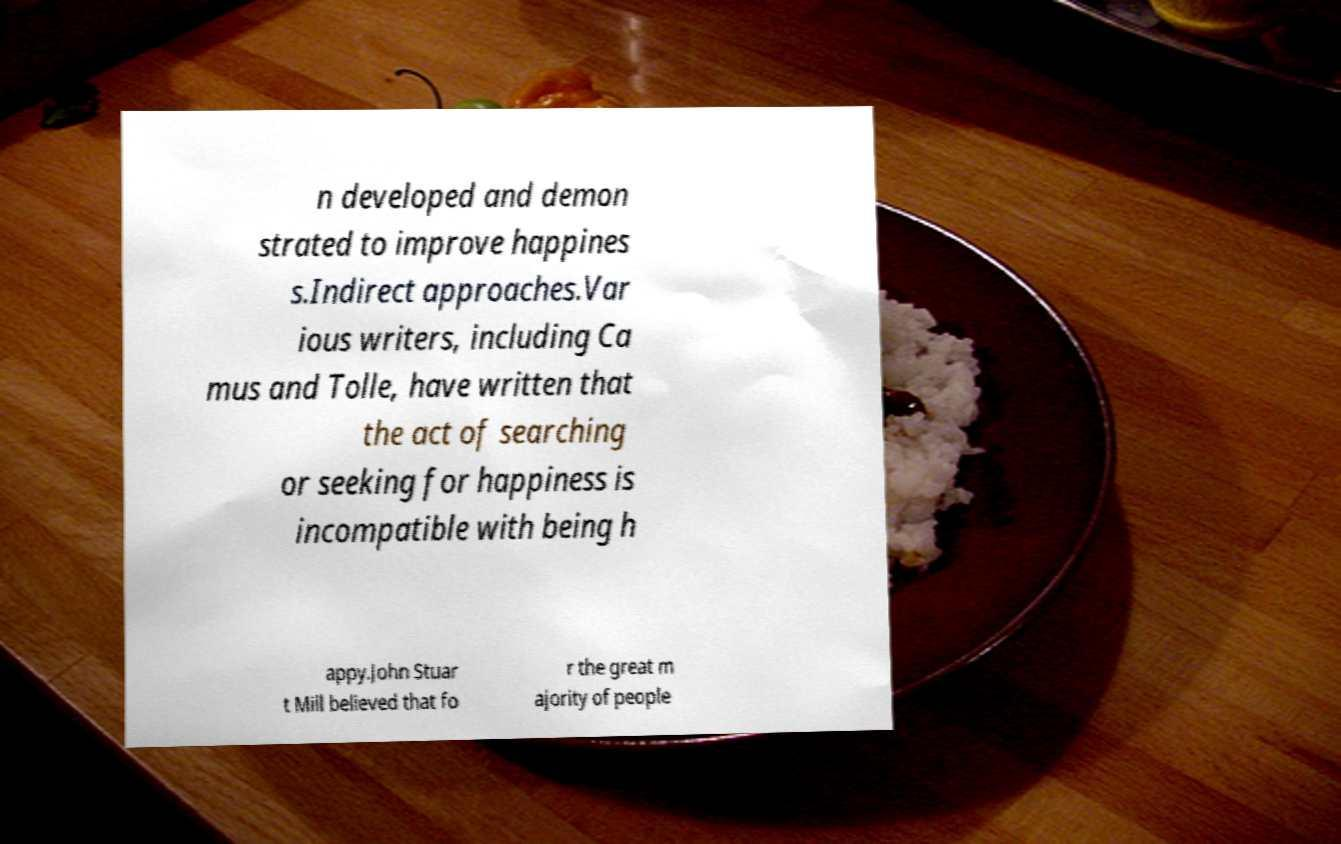I need the written content from this picture converted into text. Can you do that? n developed and demon strated to improve happines s.Indirect approaches.Var ious writers, including Ca mus and Tolle, have written that the act of searching or seeking for happiness is incompatible with being h appy.John Stuar t Mill believed that fo r the great m ajority of people 